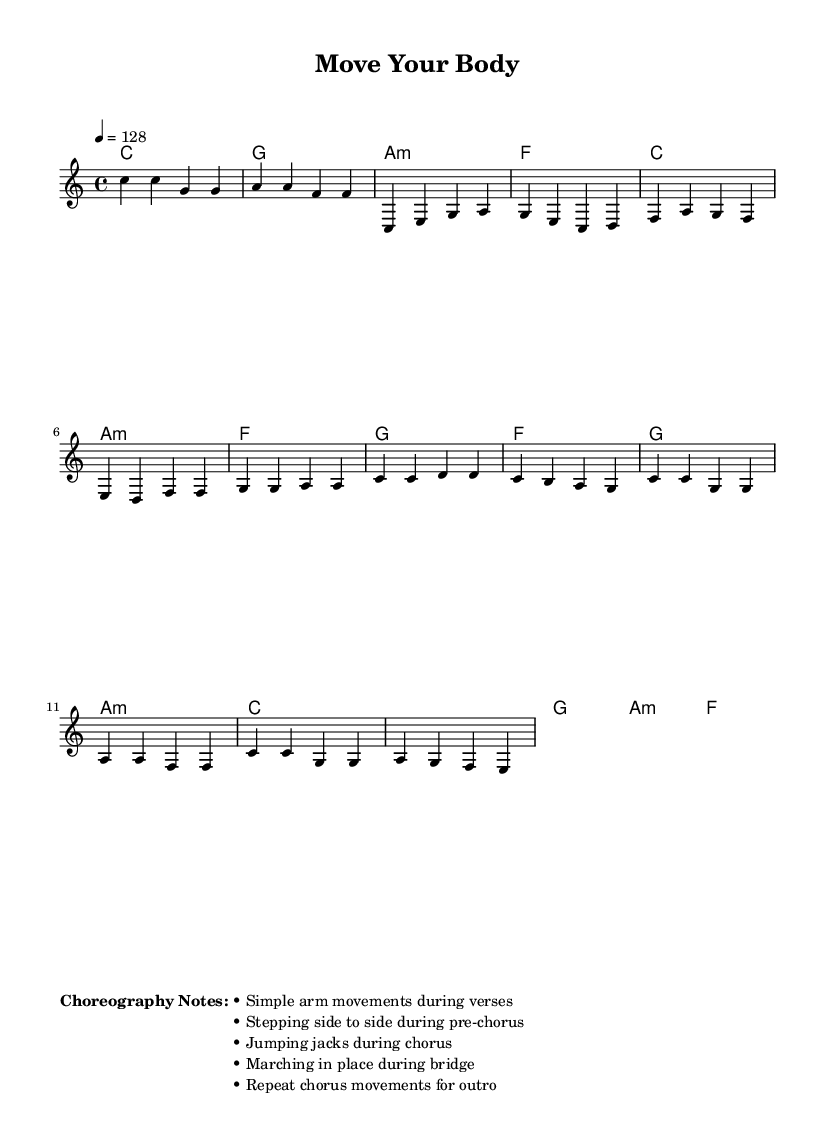What is the key signature of this music? The key signature is C major, which has no sharps or flats.
Answer: C major What is the time signature of this piece? The time signature is indicated by 4/4, meaning there are four beats in each measure.
Answer: 4/4 What is the tempo of the song? The tempo is marked as 128 beats per minute, shown with the note "4 = 128."
Answer: 128 What type of movement is suggested during the chorus? The choreography notes suggest "jumping jacks" specifically for the chorus part.
Answer: Jumping jacks How many measures are there in the verse? Counting the notes and the structure of the verse confirms that it consists of 7 measures.
Answer: 7 What are the suggested movements during the pre-chorus? The notes indicate "stepping side to side," which can be seen in the choreography descriptions.
Answer: Stepping side to side How does the melody enhance the workout experience? The melody is upbeat and simple, making it easy to follow and encouraging rhythmic movement, which is aligned with K-Pop's energetic nature.
Answer: Upbeat and simple 